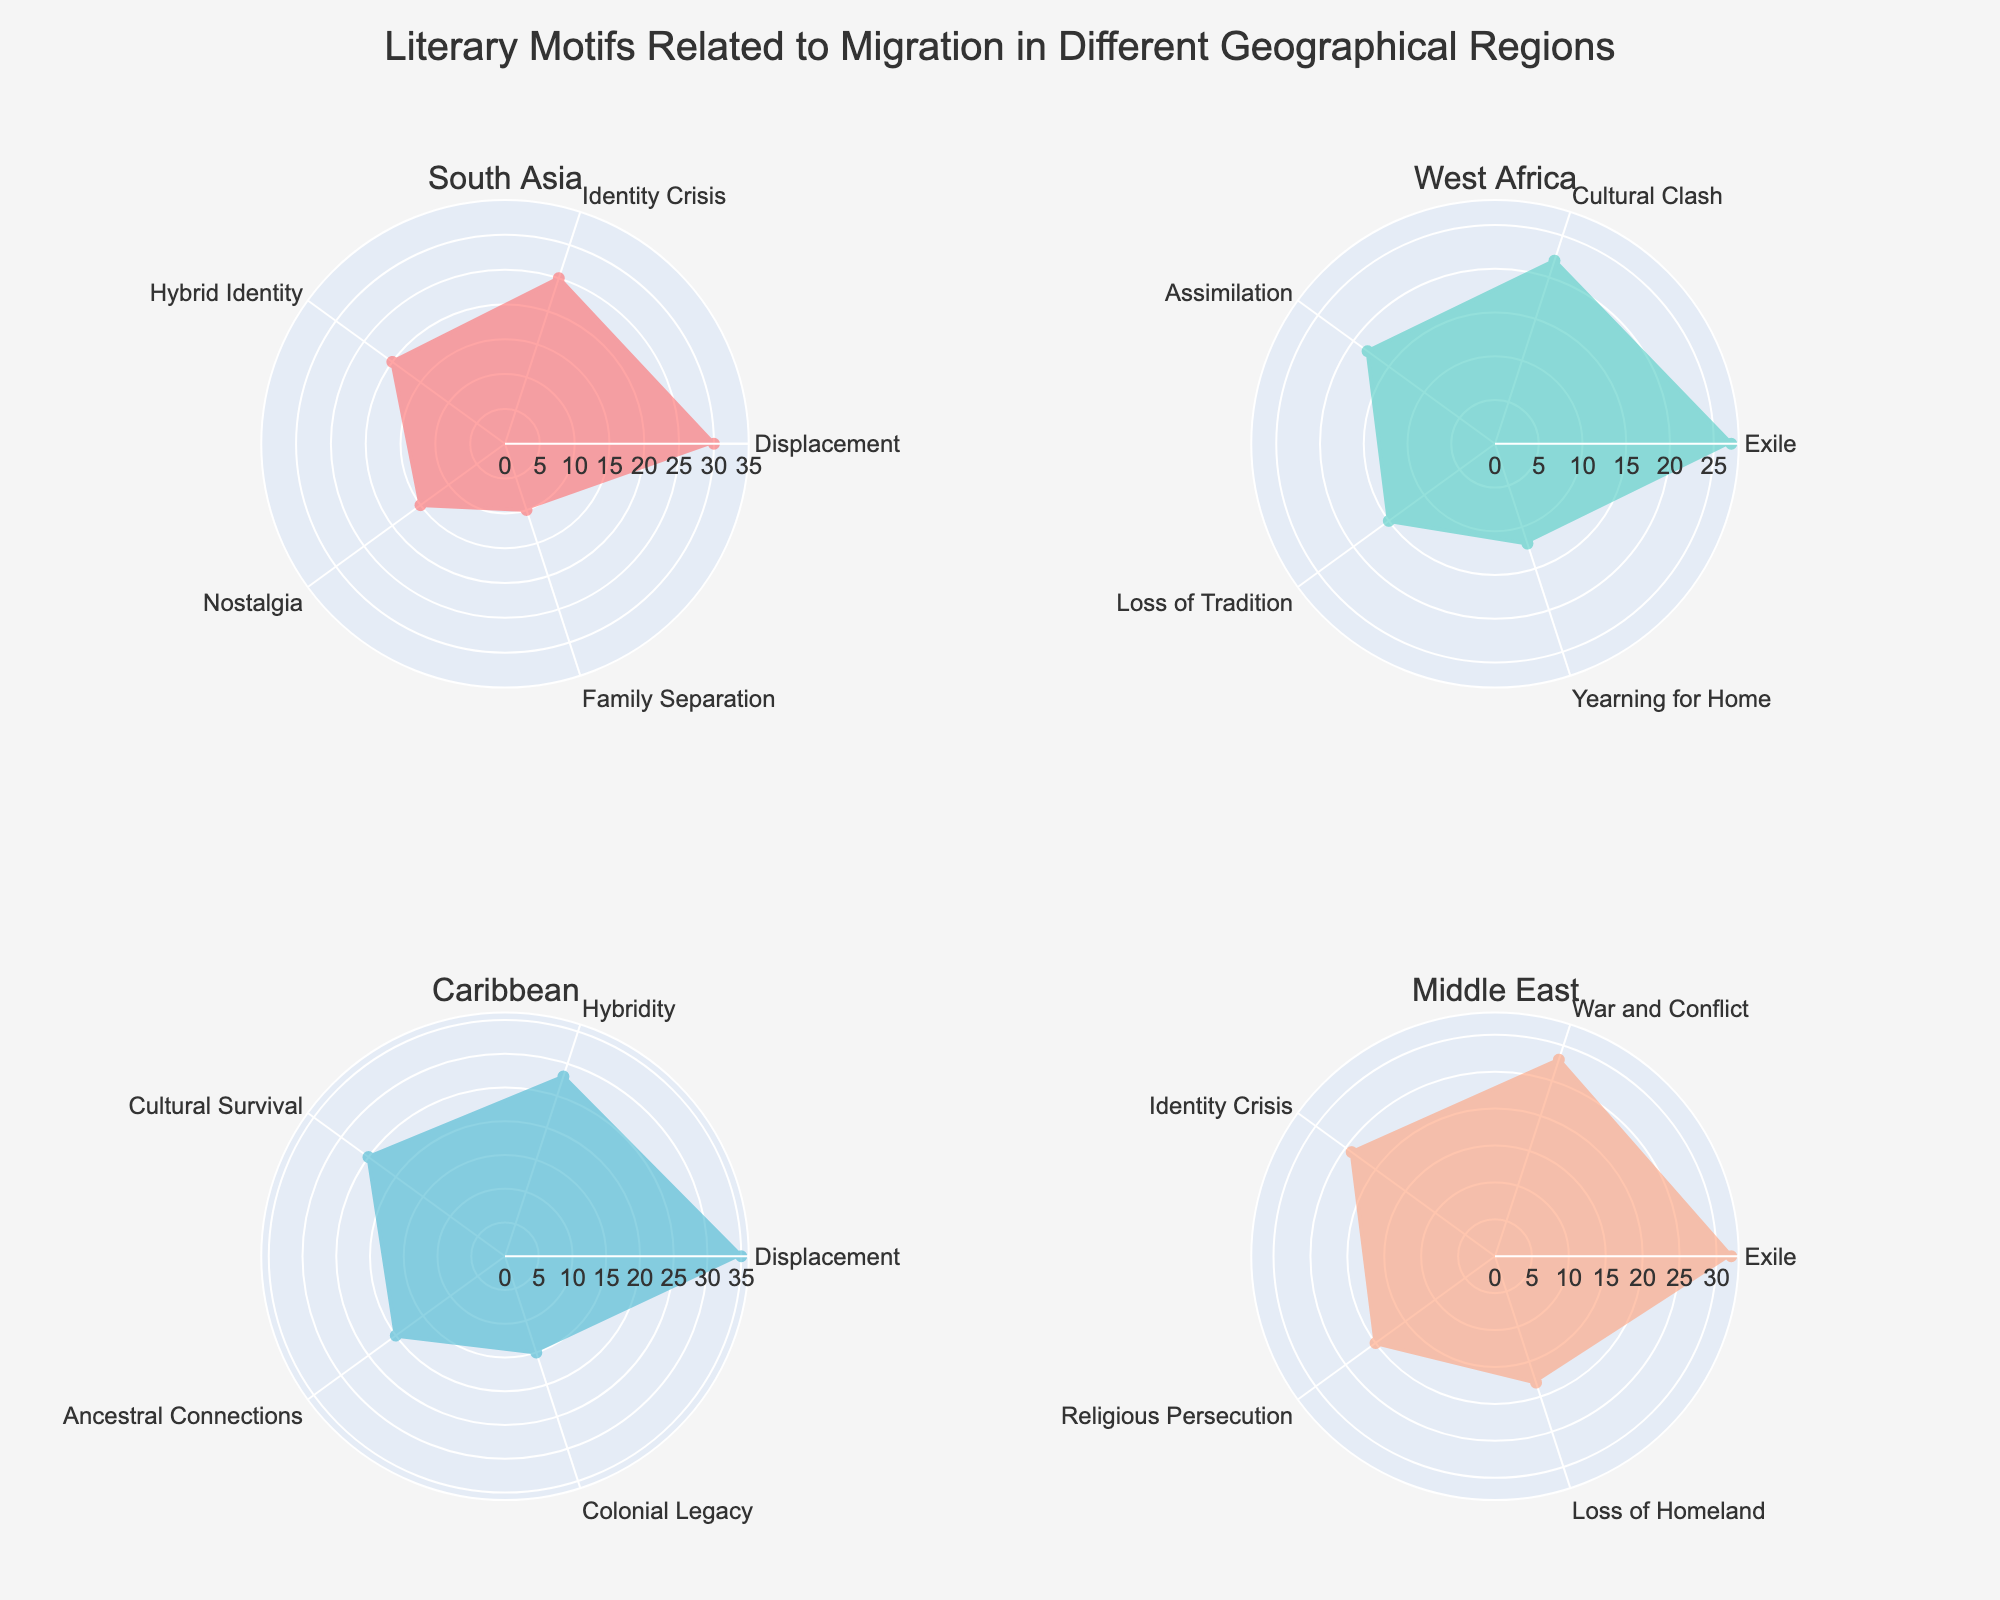What's the title of the figure? The title is usually displayed at the top of the figure. In this case, the title is provided in the data and code.
Answer: Literary Motifs Related to Migration in Different Geographical Regions How many regions are analyzed in the figure? The regions can be identified by looking at the subplot titles within the figure.
Answer: Four Which region mentions the motif "Displacement" the most? To determine this, locate each subplot for the motifs labeled "Displacement" and compare their values. The Caribbean region has the highest MentionedCount of 35 for this motif.
Answer: Caribbean What is the total MentionedCount for the motif "Identity Crisis" across all regions? Add the values of Identity Crisis from South Asia (25) and Middle East (24).
Answer: 49 Which region has the least number of motifs mentioned? Count the motifs in each region’s subplot. The region with the least motifs is the Caribbean with 5 motifs.
Answer: Caribbean Compare the mentions of "Exile" between West Africa and the Middle East. Which region has more mentions? Look at the value of "Exile" in both regions’ subplots. West Africa has 27 mentions while the Middle East has 32.
Answer: Middle East What regions have the motif "Family Separation" and what are their MentionedCount values? Check the subplot titles and then the labels within each subplot to find the motif. Only South Asia has "Family Separation" with a MentionedCount of 10.
Answer: South Asia: 10 Calculate the average MentionedCount for "Cultural Clash" and "Loss of Tradition" in West Africa. Sum the MentionedCounts for "Cultural Clash" (22) and "Loss of Tradition" (15) and divide by 2 to get the average.
Answer: 18.5 Which motif in the Caribbean region has the second-highest MentionedCount? Identify the motifs and their MentionedCount values in the Caribbean subplot. "Hybridity," with a MentionedCount of 28, is the second-highest.
Answer: Hybridity How does the MentionedCount for "War and Conflict" in the Middle East compare to "Exile" in the same region? Compare their MentionedCounts: "War and Conflict" has 28, while "Exile" has 32.
Answer: Exile has more What is the range of MentionedCount values across all motifs in South Asia? The range is calculated by subtracting the lowest MentionedCount (10) from the highest (30).
Answer: 20 